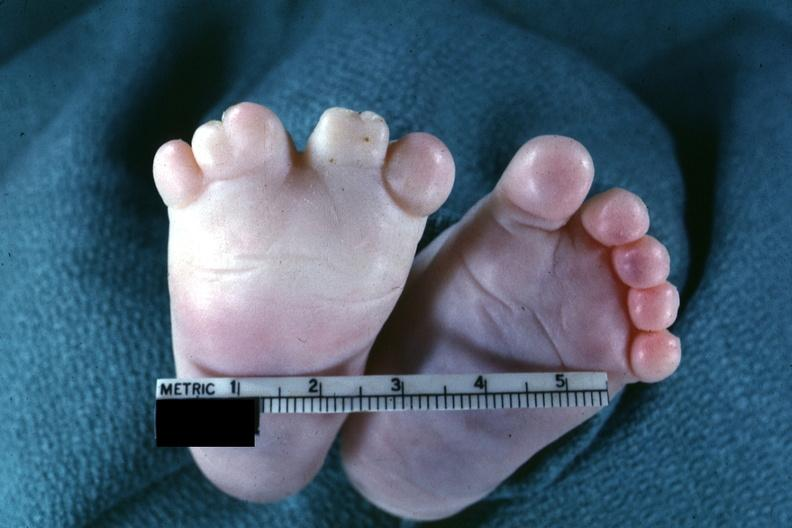re tuberculous peritonitis present?
Answer the question using a single word or phrase. No 